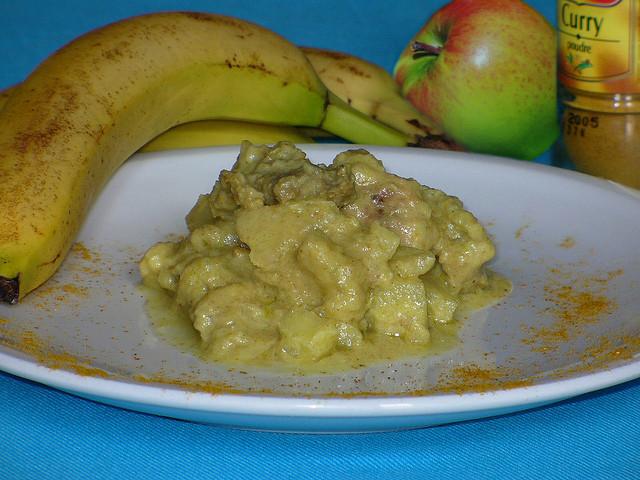How many bananas are there?
Be succinct. 3. What two fruits are shown?
Short answer required. Banana and apple. How many different types of fruit are in the picture?
Answer briefly. 2. Is the food tasty?
Keep it brief. Yes. 